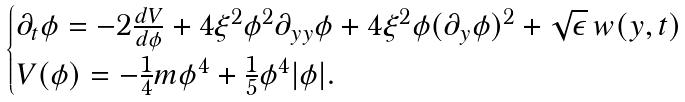Convert formula to latex. <formula><loc_0><loc_0><loc_500><loc_500>\begin{cases} \partial _ { t } \phi = - 2 \frac { d V } { d \phi } + 4 \xi ^ { 2 } \phi ^ { 2 } \partial _ { y y } \phi + 4 \xi ^ { 2 } \phi ( \partial _ { y } \phi ) ^ { 2 } + \sqrt { \epsilon } \, w ( y , t ) \\ V ( \phi ) = - \frac { 1 } { 4 } m \phi ^ { 4 } + \frac { 1 } { 5 } \phi ^ { 4 } | \phi | . \end{cases}</formula> 